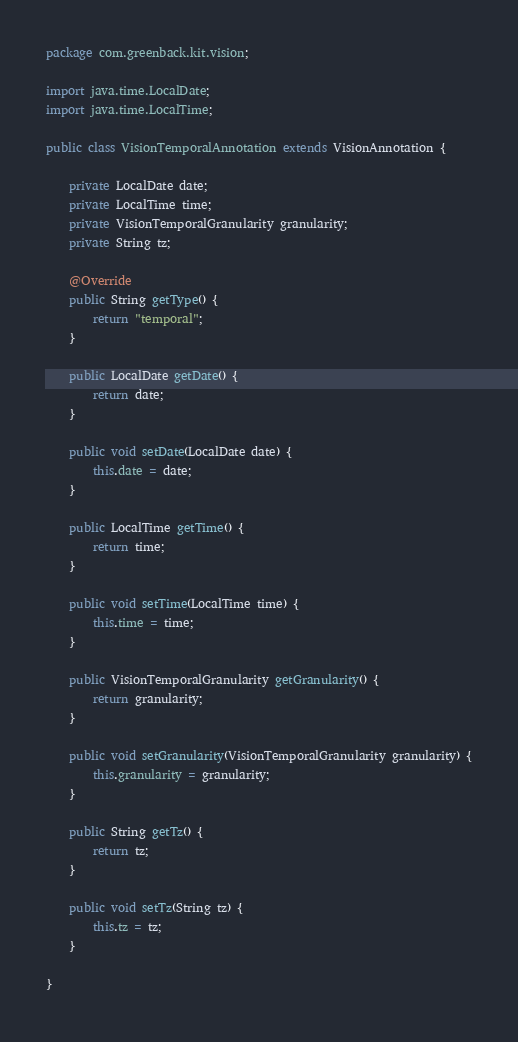<code> <loc_0><loc_0><loc_500><loc_500><_Java_>package com.greenback.kit.vision;

import java.time.LocalDate;
import java.time.LocalTime;

public class VisionTemporalAnnotation extends VisionAnnotation {
    
    private LocalDate date;
    private LocalTime time;
    private VisionTemporalGranularity granularity;
    private String tz;
    
    @Override
    public String getType() {
        return "temporal";
    }
    
    public LocalDate getDate() {
        return date;
    }

    public void setDate(LocalDate date) {
        this.date = date;
    }

    public LocalTime getTime() {
        return time;
    }

    public void setTime(LocalTime time) {
        this.time = time;
    }

    public VisionTemporalGranularity getGranularity() {
        return granularity;
    }

    public void setGranularity(VisionTemporalGranularity granularity) {
        this.granularity = granularity;
    }

    public String getTz() {
        return tz;
    }

    public void setTz(String tz) {
        this.tz = tz;
    }

}</code> 